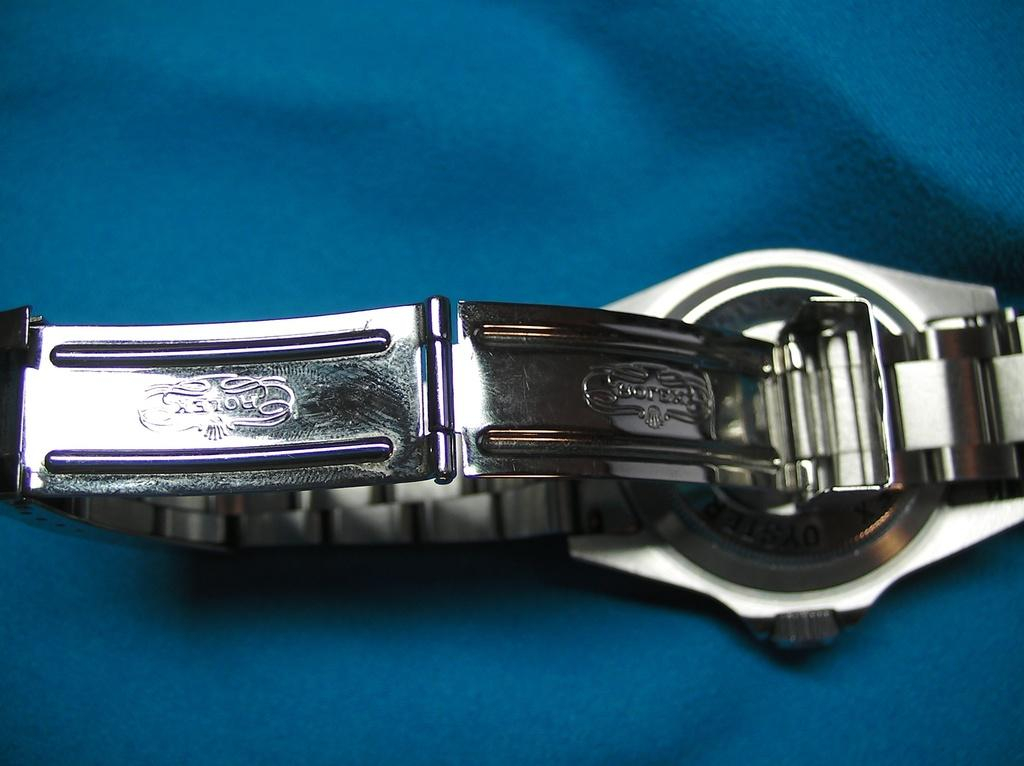<image>
Summarize the visual content of the image. A silver Rolex watch is face down showing its links. 